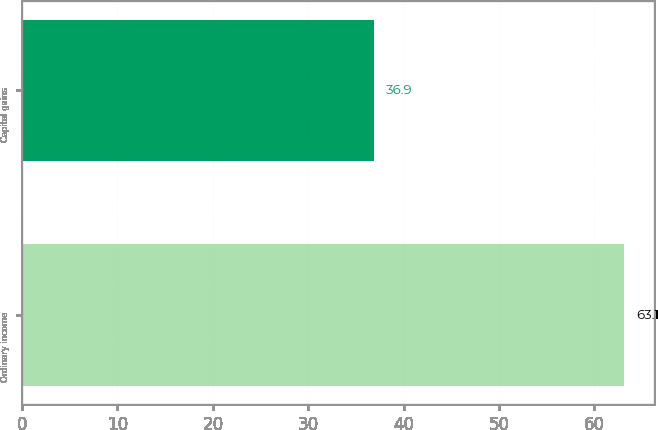<chart> <loc_0><loc_0><loc_500><loc_500><bar_chart><fcel>Ordinary income<fcel>Capital gains<nl><fcel>63.1<fcel>36.9<nl></chart> 